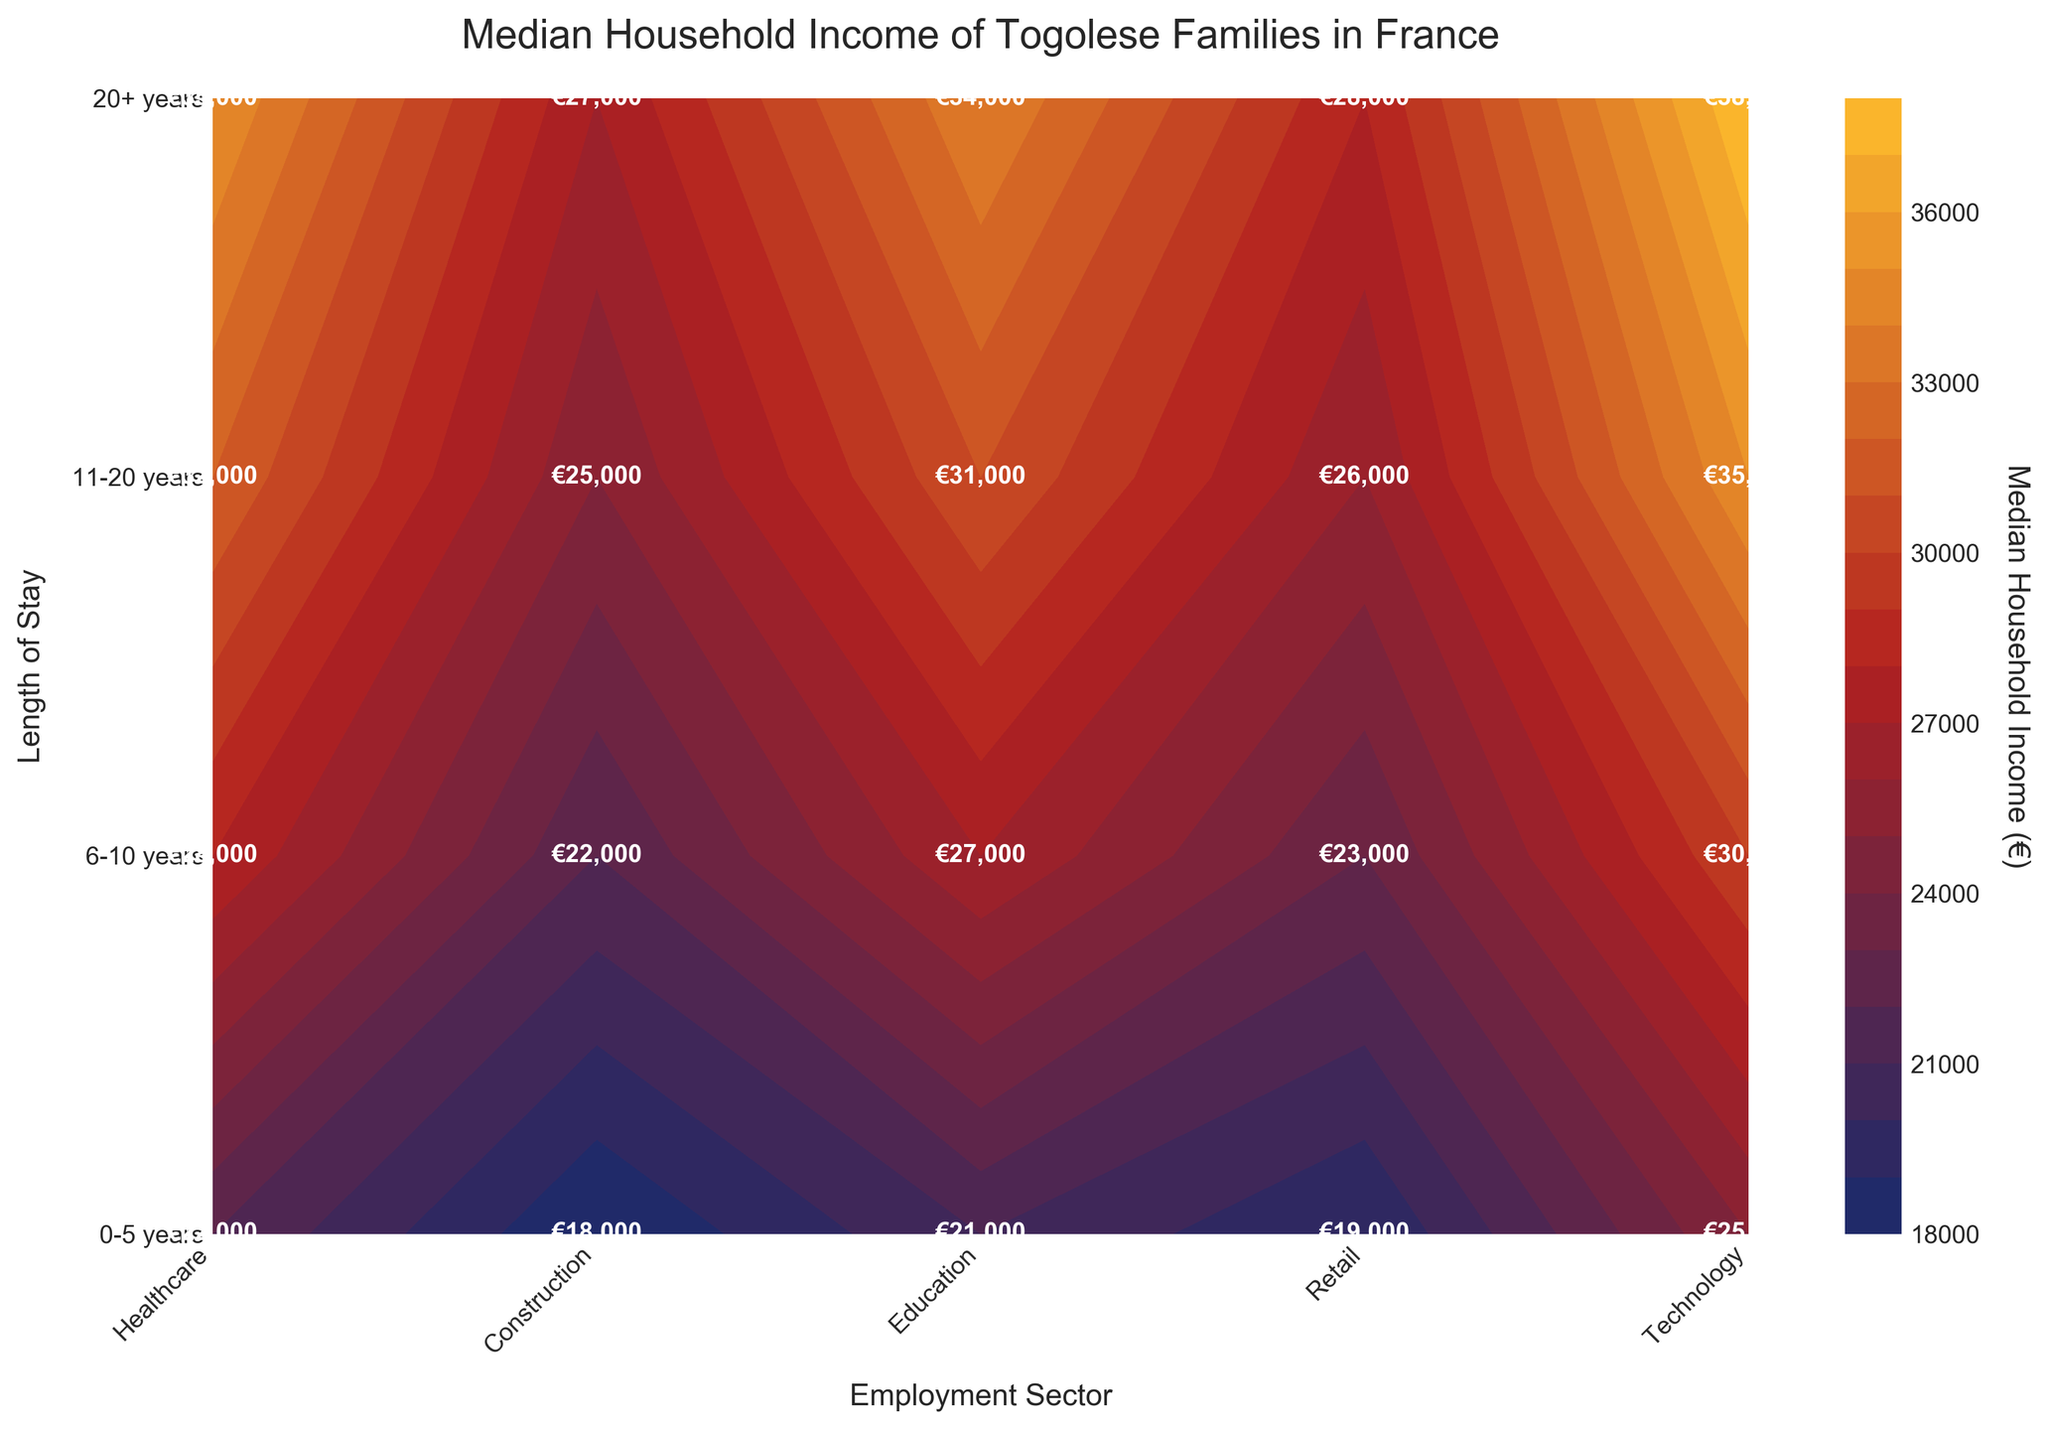Which employment sector has the highest median household income for families who stayed 20+ years? We look at the row labeled "20+ years" and compare the values in each column. The highest value in this row corresponds to the Technology sector with €38,000.
Answer: Technology What is the difference in median household income between the Retail sector for families who stayed 0-5 years and those who stayed 20+ years? The median household income for the Retail sector for 0-5 years is €19,000, and for 20+ years, it is €28,000. The difference is €28,000 - €19,000 = €9,000.
Answer: €9,000 Which length of stay has the highest median household income in the Healthcare sector? We examine the column labeled "Healthcare" and find the highest value. The highest value in the Healthcare column is for the "20+ years" group with €35,000.
Answer: 20+ years What is the median household income for the Technology sector for families who stayed between 6-10 years? We look at the intersection of the "6-10 years" row and the "Technology" column. The value is €30,000.
Answer: €30,000 Compare the median household incomes for the Construction sector between families who have stayed 0-5 years and those who stayed 6-10 years. Which is higher and by how much? The median household income for Construction for 0-5 years is €18,000, and for 6-10 years, it is €22,000. The difference is €22,000 - €18,000 = €4,000. The income is higher for the 6-10 years group.
Answer: 6-10 years by €4,000 What trend do you observe in the median household income for the Retail sector as the length of stay increases? We look at the values in the Retail sector column across each length of stay. The values increase from €19,000, to €23,000, to €26,000, to €28,000. The trend is that the median household income increases as the length of stay increases.
Answer: Increasing For families who have stayed between 11-20 years, which sector has the second-highest median household income? We look at the row labeled "11-20 years" and identify the second-highest value after Technology (€35,000). The next highest value is in Healthcare (€32,000).
Answer: Healthcare What is the average median household income for the Education sector across all length of stay categories? We sum the values in the Education column: €21,000 + €27,000 + €31,000 + €34,000 = €113,000. There are 4 data points, so the average is €113,000 / 4 = €28,250.
Answer: €28,250 Identify the lowest median household income value in the entire chart and its corresponding sector and length of stay. By examining all the values, the lowest median household income is €18,000 in the Construction sector for the 0-5 years length of stay.
Answer: Construction, 0-5 years Which length of stay groups have the same median household income in the Technology sector? We look at the values in the Technology column and find that the groups "0-5 years" and "20+ years" are not the same. There are no repeated values in Technology sector.
Answer: None 